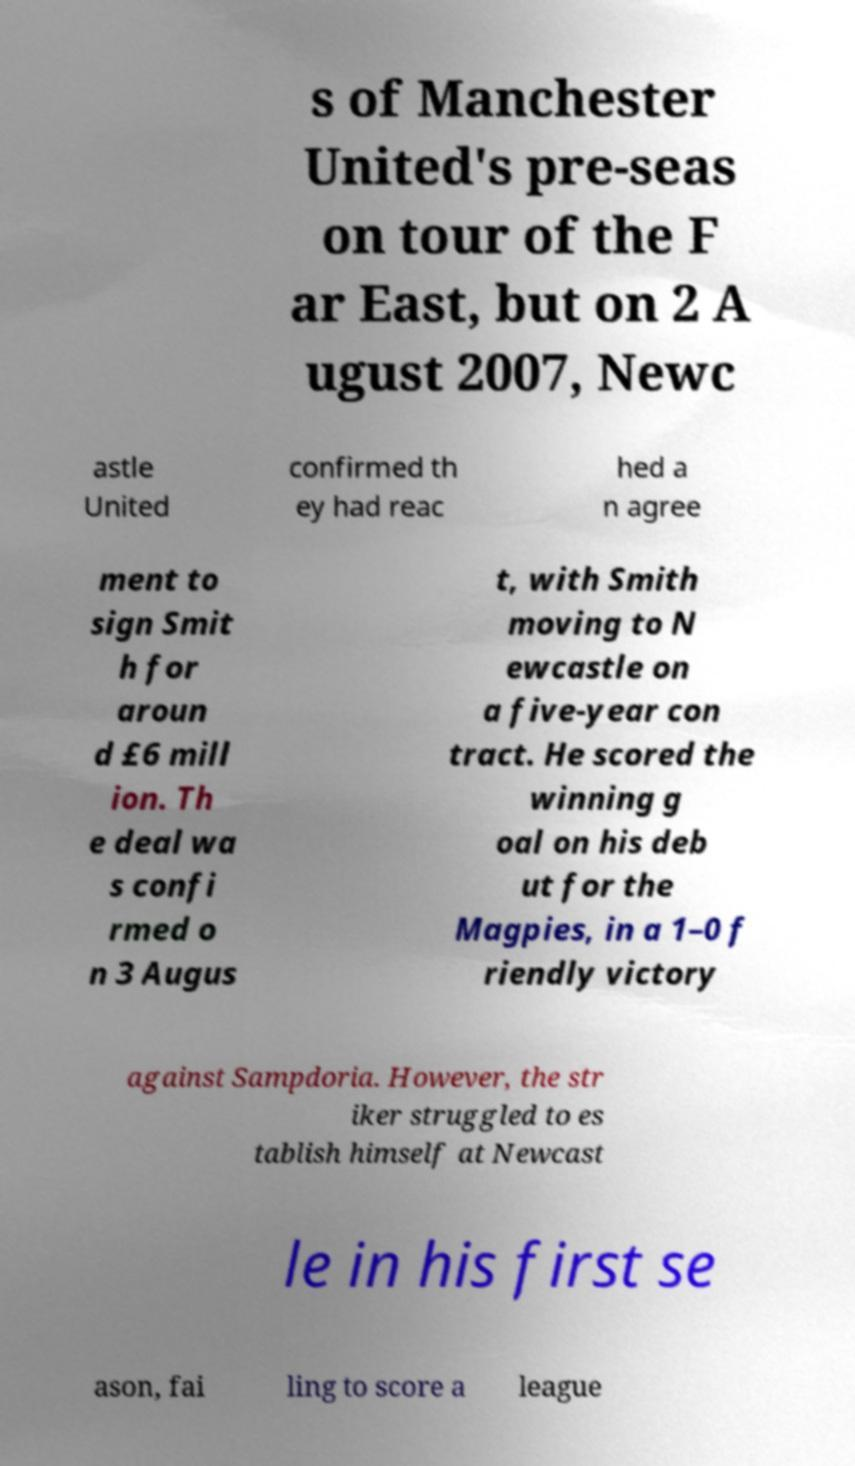Could you assist in decoding the text presented in this image and type it out clearly? s of Manchester United's pre-seas on tour of the F ar East, but on 2 A ugust 2007, Newc astle United confirmed th ey had reac hed a n agree ment to sign Smit h for aroun d £6 mill ion. Th e deal wa s confi rmed o n 3 Augus t, with Smith moving to N ewcastle on a five-year con tract. He scored the winning g oal on his deb ut for the Magpies, in a 1–0 f riendly victory against Sampdoria. However, the str iker struggled to es tablish himself at Newcast le in his first se ason, fai ling to score a league 